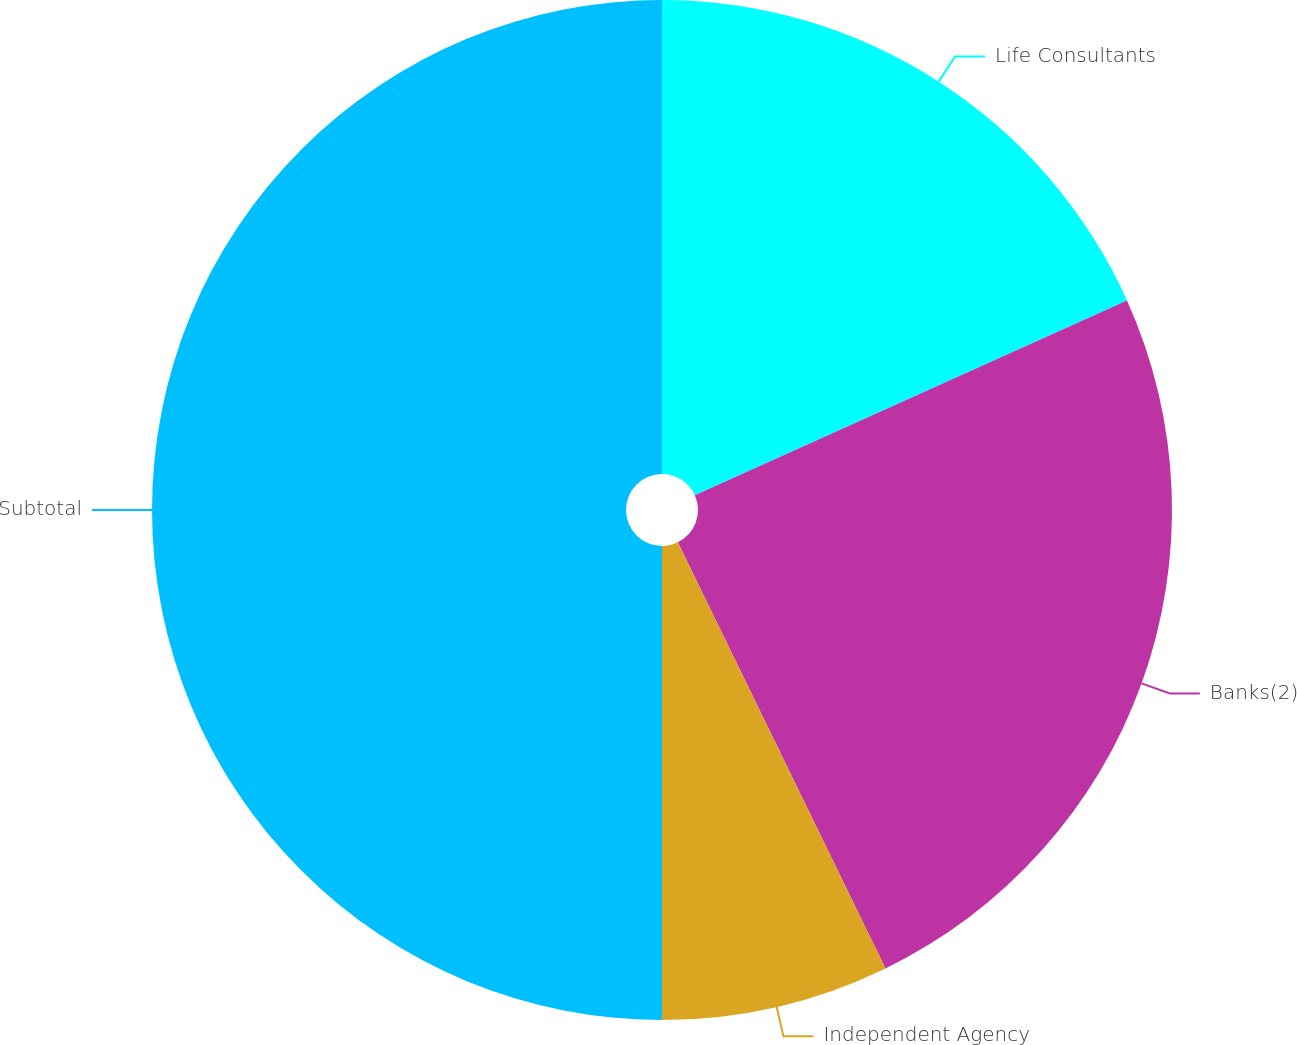Convert chart to OTSL. <chart><loc_0><loc_0><loc_500><loc_500><pie_chart><fcel>Life Consultants<fcel>Banks(2)<fcel>Independent Agency<fcel>Subtotal<nl><fcel>18.26%<fcel>24.52%<fcel>7.22%<fcel>50.0%<nl></chart> 